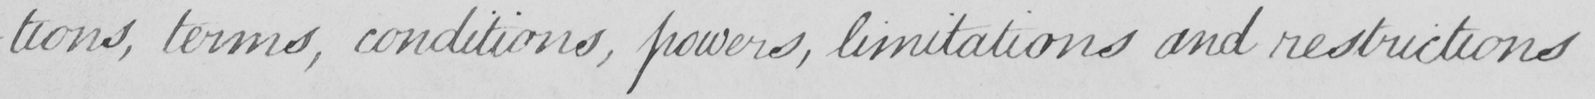Can you tell me what this handwritten text says? -tions , terms , conditions , powers , limitations and restrictions 